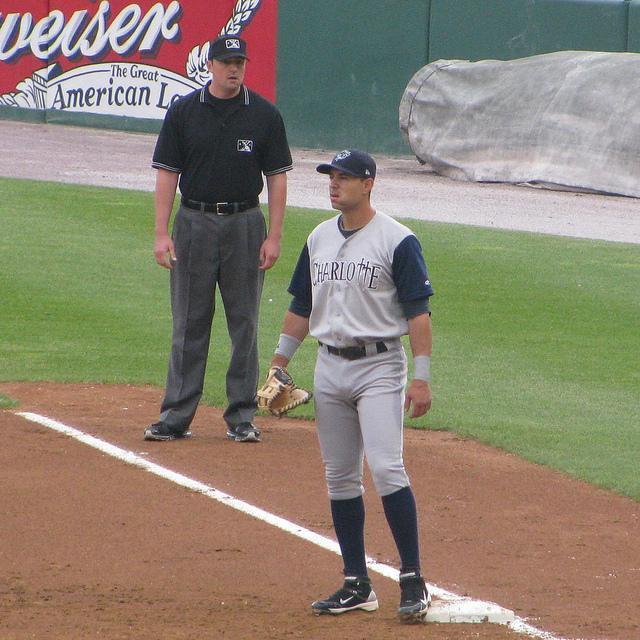What is the person dress in black's job?
Indicate the correct choice and explain in the format: 'Answer: answer
Rationale: rationale.'
Options: Umpire, referee, 1st base, catcher. Answer: referee.
Rationale: They are not in the player uniform, and their job is to watch and make sure the players are correctly following the rules. 